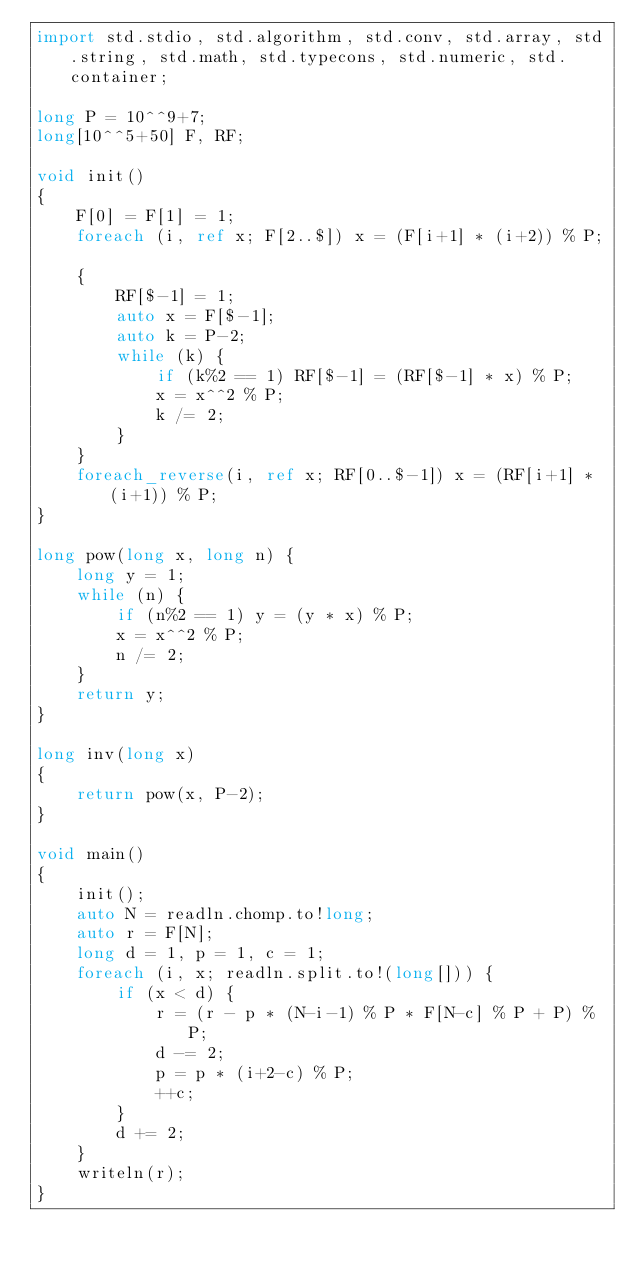Convert code to text. <code><loc_0><loc_0><loc_500><loc_500><_D_>import std.stdio, std.algorithm, std.conv, std.array, std.string, std.math, std.typecons, std.numeric, std.container;

long P = 10^^9+7;
long[10^^5+50] F, RF;

void init()
{
    F[0] = F[1] = 1;
    foreach (i, ref x; F[2..$]) x = (F[i+1] * (i+2)) % P;

    {
        RF[$-1] = 1;
        auto x = F[$-1];
        auto k = P-2;
        while (k) {
            if (k%2 == 1) RF[$-1] = (RF[$-1] * x) % P;
            x = x^^2 % P;
            k /= 2;
        }
    }
    foreach_reverse(i, ref x; RF[0..$-1]) x = (RF[i+1] * (i+1)) % P;
}

long pow(long x, long n) {
    long y = 1;
    while (n) {
        if (n%2 == 1) y = (y * x) % P;
        x = x^^2 % P;
        n /= 2;
    }
    return y;
}

long inv(long x)
{
    return pow(x, P-2);
}

void main()
{
    init();
    auto N = readln.chomp.to!long;
    auto r = F[N];
    long d = 1, p = 1, c = 1;
    foreach (i, x; readln.split.to!(long[])) {
        if (x < d) {
            r = (r - p * (N-i-1) % P * F[N-c] % P + P) % P;
            d -= 2;
            p = p * (i+2-c) % P;
            ++c;
        }
        d += 2;
    }
    writeln(r);
}</code> 